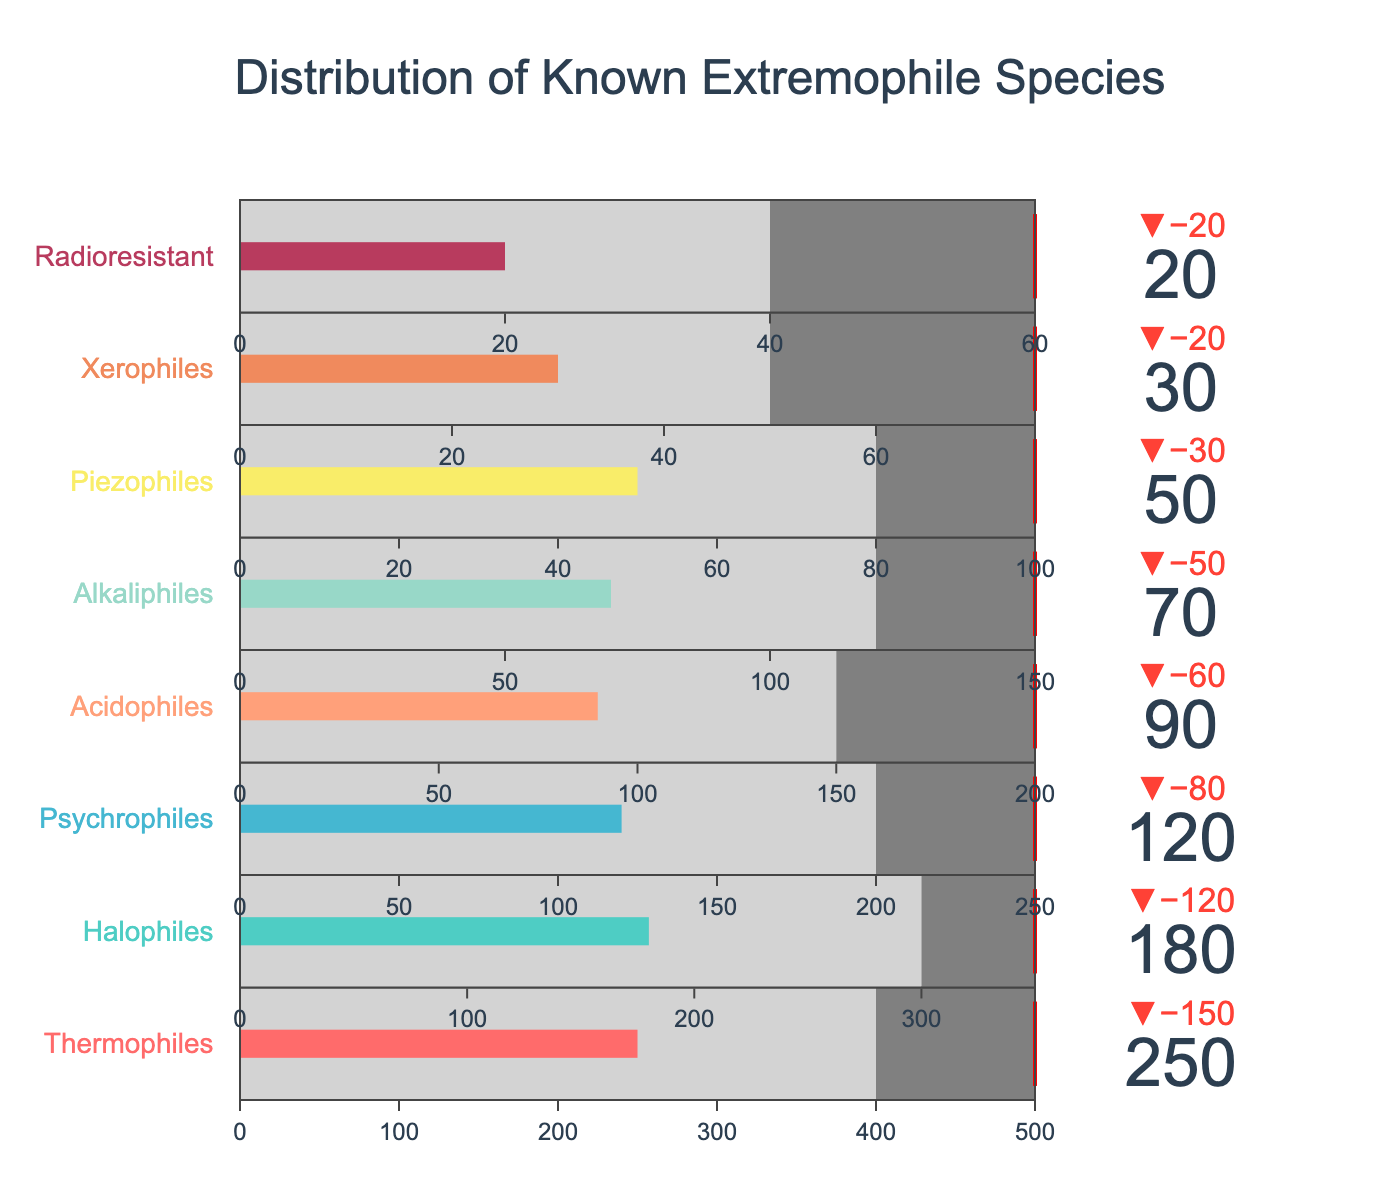what is the title of the figure? The title is typically located at the top of the figure. Here, it describes the distribution of known extremophile species.
Answer: Distribution of Known Extremophile Species Which extremophile category has the highest actual count? The figure shows the actual counts next to each category's bar. The Thermophiles have the highest count at 250.
Answer: Thermophiles Which extremophile category has the smallest difference between actual and target values? To find this, subtract the actual value from the target value for each category. The Radioresistant category has the smallest difference: 60 - 20 = 40.
Answer: Radioresistant What is the average target value across all extremophile categories? Add all the target values: 500 + 350 + 250 + 200 + 150 + 100 + 75 + 60 = 1685. Divide by 8 (the number of categories): 1685 / 8 = 210.625.
Answer: 210.625 Which category's actual count is closest to its comparative value? Compare the actual and comparative values for each category. The category with the smallest difference is Radioresistant:
Answer: Radioresistant How much higher is the target value compared to the actual count for Halophiles? Subtract the actual count from the target value: 350 - 180 = 170.
Answer: 170 What percentage of the target value does the actual count of Acidophiles represent? Divide the actual count by the target value and then multiply by 100: (90 / 200) * 100 = 45%.
Answer: 45% Which category has a comparative value more than double its actual count? Compare each category's actual and comparative values. The Thermophiles (250 actual vs 400 comparative) is the only category where the comparative value is more than double the actual count.
Answer: Thermophiles How many categories have actual counts that fall short of their comparative values? Check for each category where the actual value is less than the comparative value. All categories meet this condition, totaling eight.
Answer: Eight What is the median target value across all categories? List the target values in ascending order: 60, 75, 100, 150, 200, 250, 350, 500. The median is the average of the fourth and fifth values: (150 + 200) / 2 = 175.
Answer: 175 